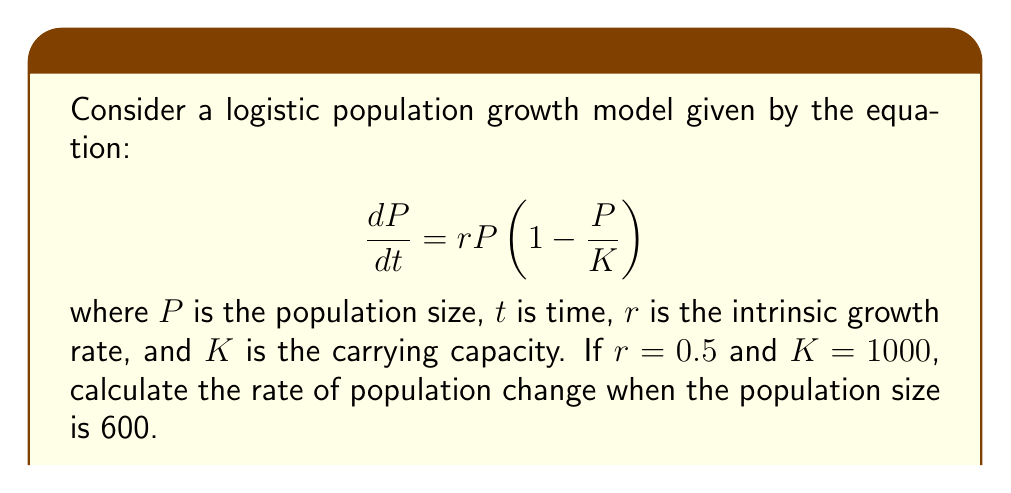Could you help me with this problem? To solve this problem, we'll follow these steps:

1) We're given the logistic growth model:
   $$\frac{dP}{dt} = rP\left(1 - \frac{P}{K}\right)$$

2) We know the following parameters:
   $r = 0.5$
   $K = 1000$
   $P = 600$

3) Let's substitute these values into the equation:
   $$\frac{dP}{dt} = 0.5 \cdot 600 \left(1 - \frac{600}{1000}\right)$$

4) Simplify the expression inside the parentheses:
   $$\frac{dP}{dt} = 0.5 \cdot 600 \left(1 - 0.6\right)$$
   $$\frac{dP}{dt} = 0.5 \cdot 600 \cdot 0.4$$

5) Calculate the final result:
   $$\frac{dP}{dt} = 0.5 \cdot 600 \cdot 0.4 = 300 \cdot 0.4 = 120$$

Therefore, when the population size is 600, the rate of change is 120 individuals per unit time.
Answer: 120 individuals per unit time 